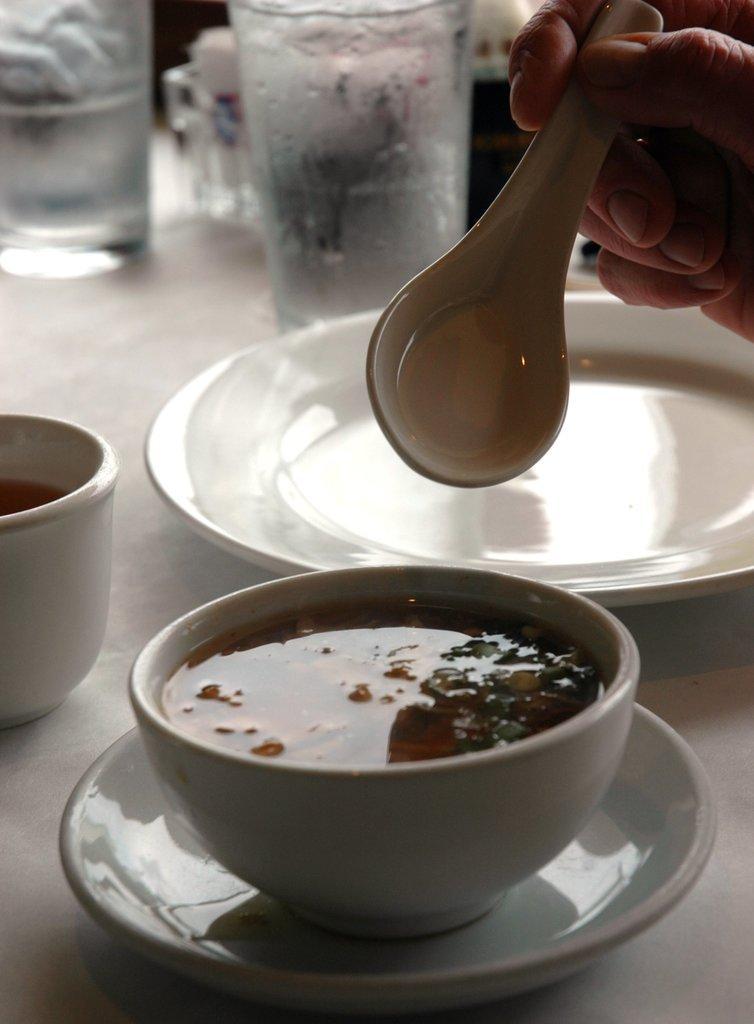Please provide a concise description of this image. Here we can see a bowl of soup placed on a table and here we can see a hand holding a spoon and behind that there is a glass of water 